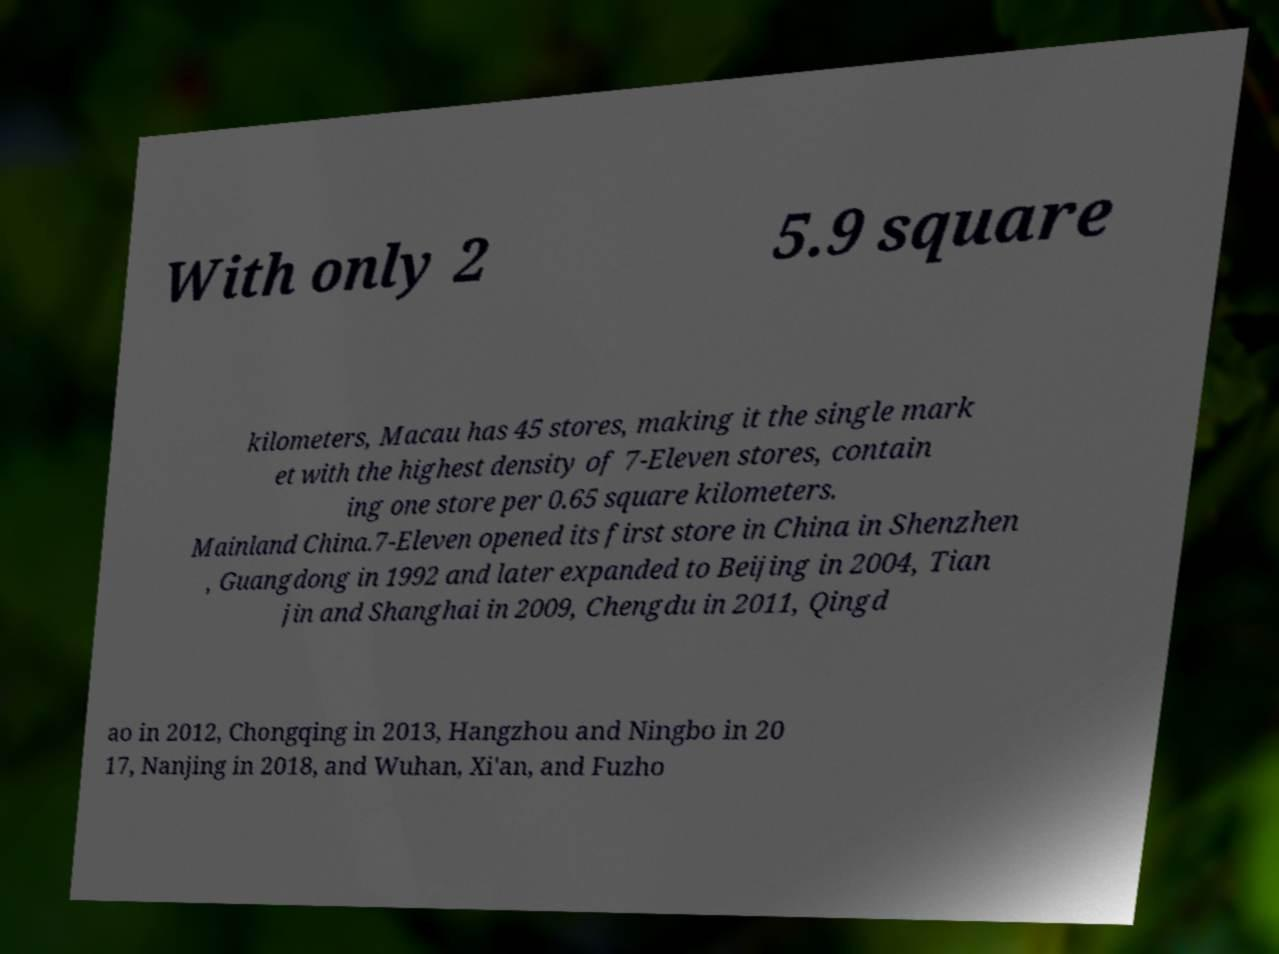Could you assist in decoding the text presented in this image and type it out clearly? With only 2 5.9 square kilometers, Macau has 45 stores, making it the single mark et with the highest density of 7-Eleven stores, contain ing one store per 0.65 square kilometers. Mainland China.7-Eleven opened its first store in China in Shenzhen , Guangdong in 1992 and later expanded to Beijing in 2004, Tian jin and Shanghai in 2009, Chengdu in 2011, Qingd ao in 2012, Chongqing in 2013, Hangzhou and Ningbo in 20 17, Nanjing in 2018, and Wuhan, Xi'an, and Fuzho 